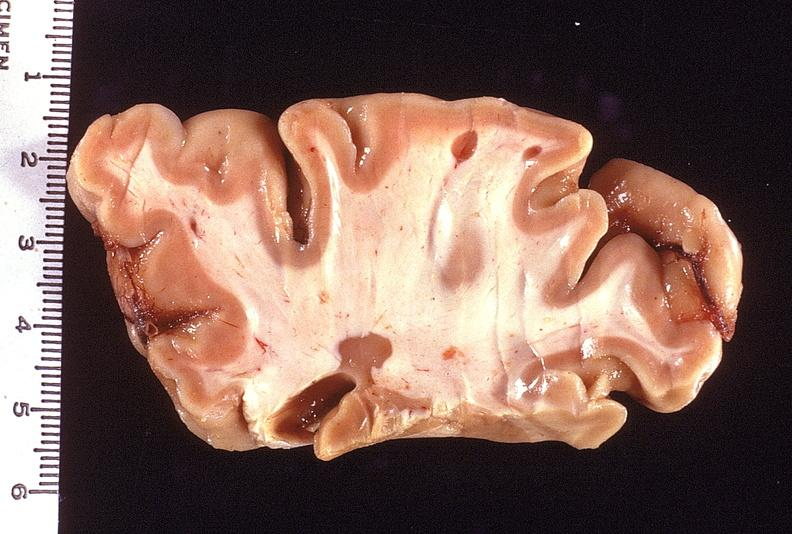s nervous present?
Answer the question using a single word or phrase. Yes 